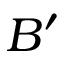Convert formula to latex. <formula><loc_0><loc_0><loc_500><loc_500>B ^ { \prime }</formula> 